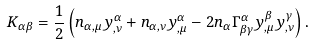<formula> <loc_0><loc_0><loc_500><loc_500>K _ { \alpha \beta } = \frac { 1 } { 2 } \left ( n _ { \alpha , \mu } y _ { , \nu } ^ { \alpha } + n _ { \alpha , \nu } y _ { , \mu } ^ { \alpha } - 2 n _ { \alpha } \Gamma _ { \beta \gamma } ^ { \alpha } y _ { , \mu } ^ { \beta } y _ { , \nu } ^ { \gamma } \right ) .</formula> 